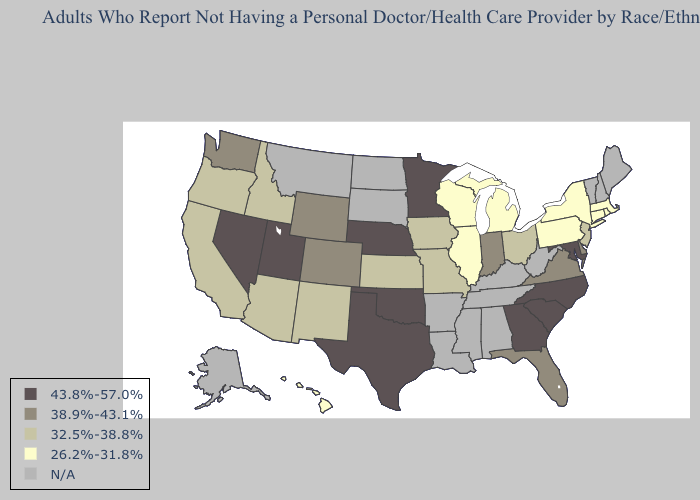What is the highest value in states that border Louisiana?
Short answer required. 43.8%-57.0%. Name the states that have a value in the range N/A?
Keep it brief. Alabama, Alaska, Arkansas, Kentucky, Louisiana, Maine, Mississippi, Montana, New Hampshire, North Dakota, South Dakota, Tennessee, Vermont, West Virginia. Does the first symbol in the legend represent the smallest category?
Concise answer only. No. What is the value of Hawaii?
Quick response, please. 26.2%-31.8%. Which states hav the highest value in the MidWest?
Concise answer only. Minnesota, Nebraska. What is the highest value in the Northeast ?
Give a very brief answer. 32.5%-38.8%. Does the first symbol in the legend represent the smallest category?
Answer briefly. No. Among the states that border West Virginia , does Maryland have the highest value?
Answer briefly. Yes. Name the states that have a value in the range 38.9%-43.1%?
Concise answer only. Colorado, Delaware, Florida, Indiana, Virginia, Washington, Wyoming. Does Hawaii have the lowest value in the West?
Keep it brief. Yes. Name the states that have a value in the range 32.5%-38.8%?
Keep it brief. Arizona, California, Idaho, Iowa, Kansas, Missouri, New Jersey, New Mexico, Ohio, Oregon. Among the states that border Wyoming , does Utah have the highest value?
Write a very short answer. Yes. Is the legend a continuous bar?
Give a very brief answer. No. Name the states that have a value in the range 26.2%-31.8%?
Answer briefly. Connecticut, Hawaii, Illinois, Massachusetts, Michigan, New York, Pennsylvania, Rhode Island, Wisconsin. 